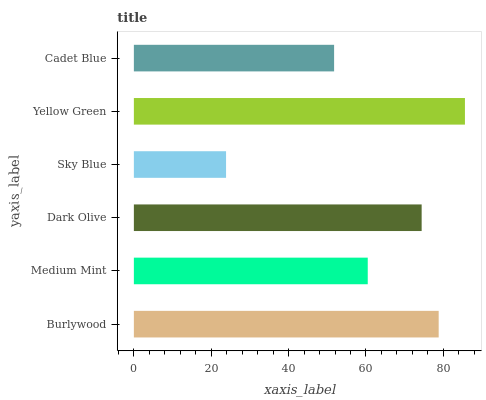Is Sky Blue the minimum?
Answer yes or no. Yes. Is Yellow Green the maximum?
Answer yes or no. Yes. Is Medium Mint the minimum?
Answer yes or no. No. Is Medium Mint the maximum?
Answer yes or no. No. Is Burlywood greater than Medium Mint?
Answer yes or no. Yes. Is Medium Mint less than Burlywood?
Answer yes or no. Yes. Is Medium Mint greater than Burlywood?
Answer yes or no. No. Is Burlywood less than Medium Mint?
Answer yes or no. No. Is Dark Olive the high median?
Answer yes or no. Yes. Is Medium Mint the low median?
Answer yes or no. Yes. Is Yellow Green the high median?
Answer yes or no. No. Is Yellow Green the low median?
Answer yes or no. No. 